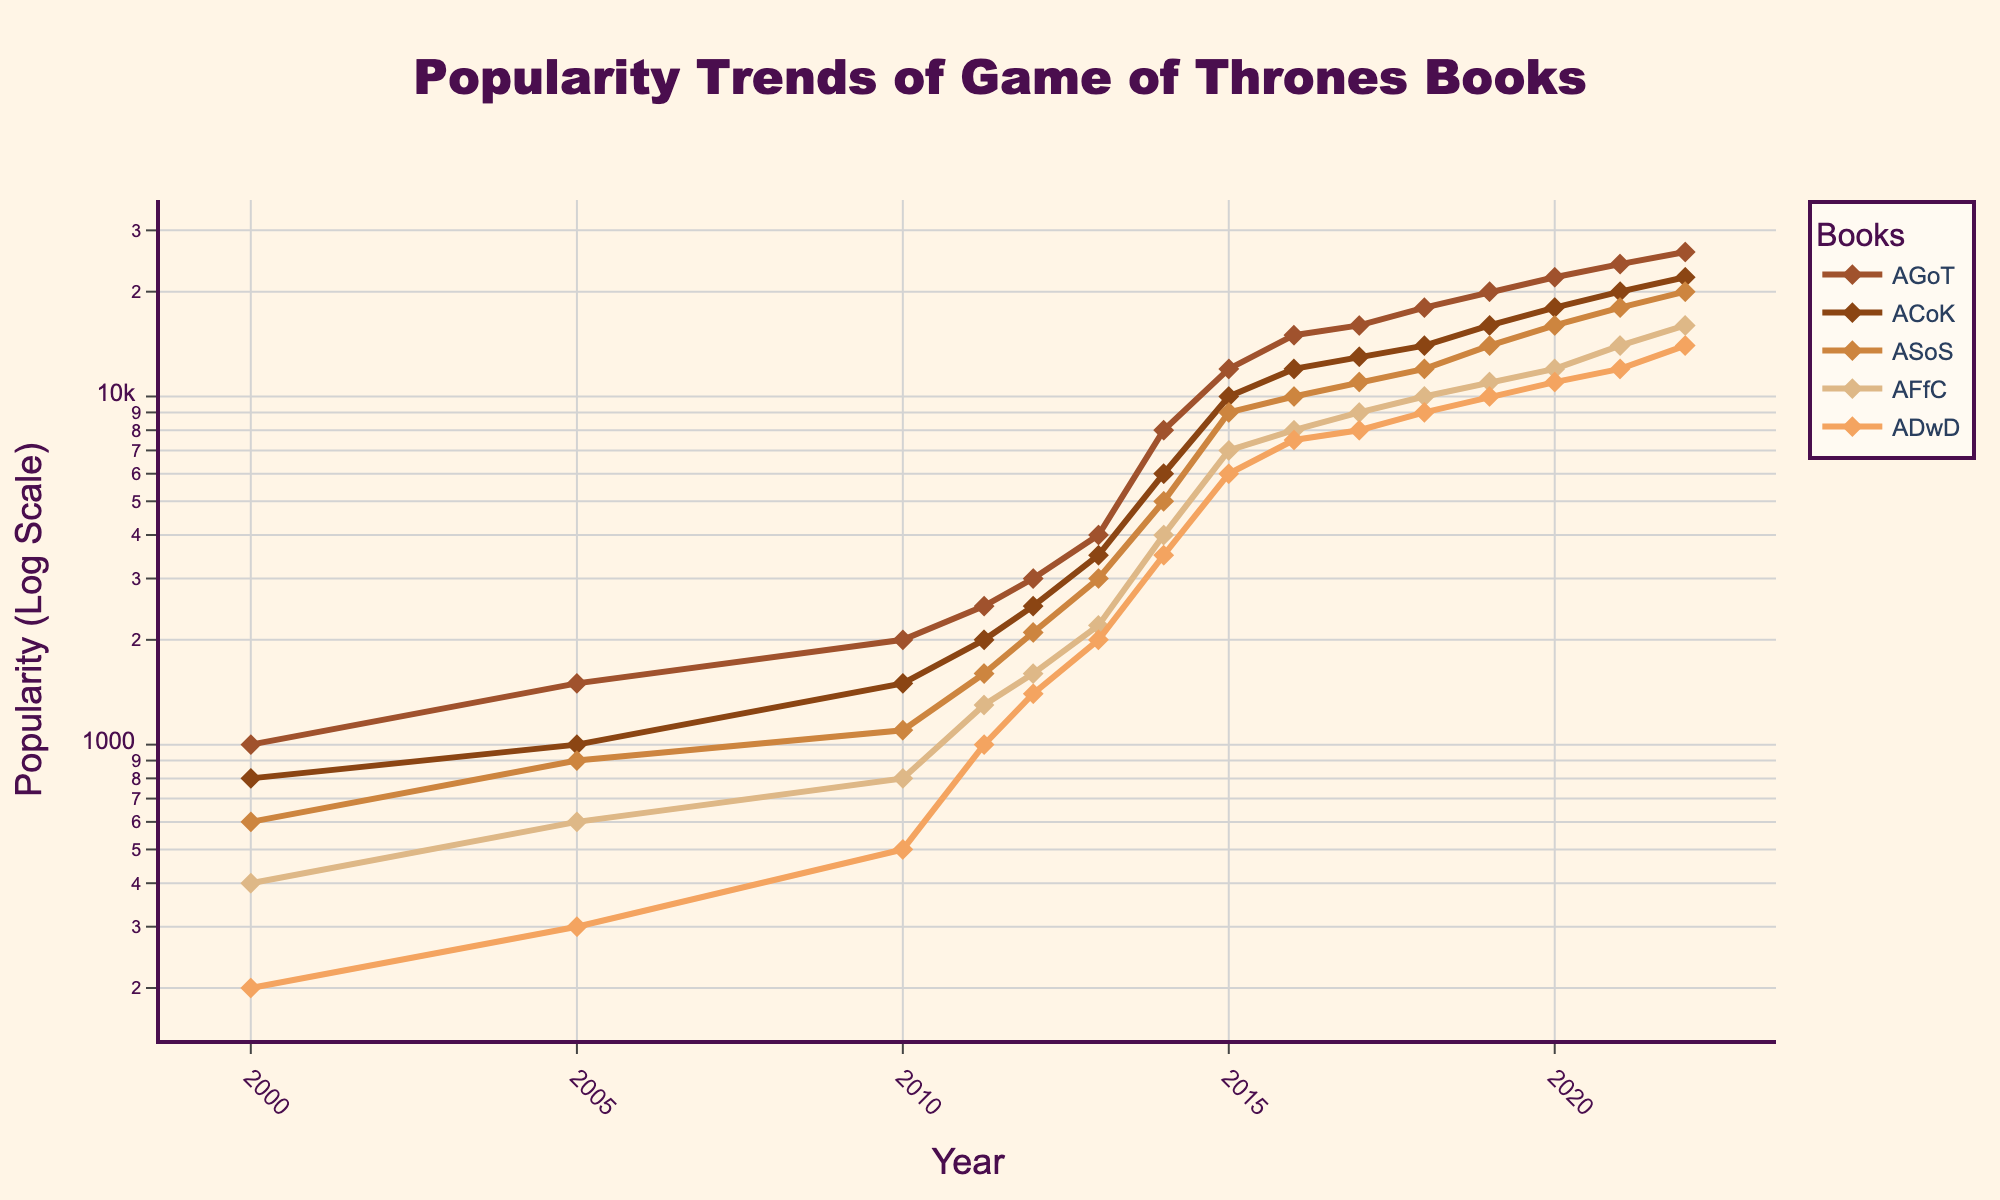What's the title of the plot? The title of the plot is explicitly mentioned at the top, as shown in the rendered figure.
Answer: Popularity Trends of Game of Thrones Books How many books are represented in the plot? By observing the legend in the figure, we can count the number of different book titles listed.
Answer: Five Which book had the highest popularity in 2022? We look at the y-values at the 2022 mark and identify which one is the highest.
Answer: AGoT In which year did AGoT's popularity first exceed 20000? By following the line for AGoT (brown color) and noting where it crosses the 20000 mark on the y-axis, we identify the corresponding year on the x-axis.
Answer: 2019 What's the difference in popularity for ASoS between 2014 and 2022? Find the y-values for 2014 and 2022 for ASoS, then subtract the former from the latter.
Answer: 15000 How did the popularity for ADwD change from 2011 to 2014? Check the y-values for ADwD in 2011 and 2014, then compute the difference to determine the change.
Answer: Increased by 2500 Did any book's popularity decrease over the years? Observe all the plotted lines from start to end to determine if any y-values dropped.
Answer: No Compare the popularity of ACoK and ASoS in 2013. Which book was more popular? Locate the y-values for both ACoK and ASoS in 2013, and compare them.
Answer: ASoS What is the trend of AFfC's popularity from 2011 to 2015? Observe the section of AFfC's line (beige color) between 2011 and 2015 to identify if it increases, decreases, or remains steady.
Answer: Increasing What can be inferred about the show's release impact on the book's popularity? Compare the y-values before and after the show's first airing date in April 2011, noting any significant changes in trends.
Answer: Significant increase 